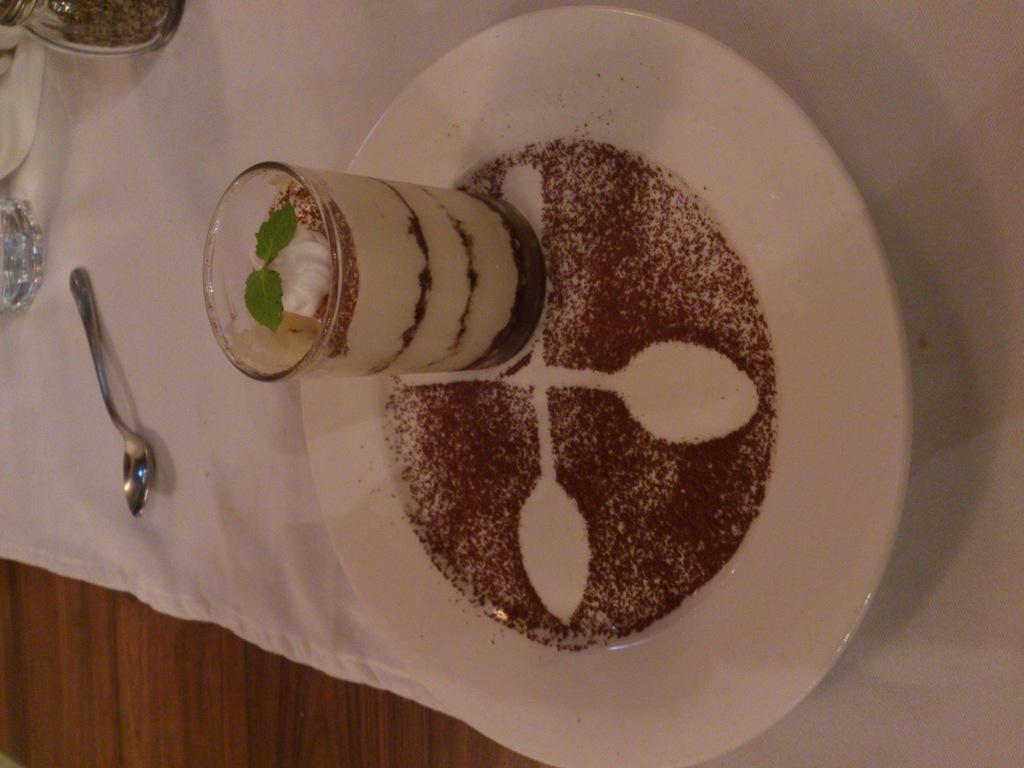How would you summarize this image in a sentence or two? It's an ice cream glass in a white color plate. On the left side there is a spoon on the white color cloth. 